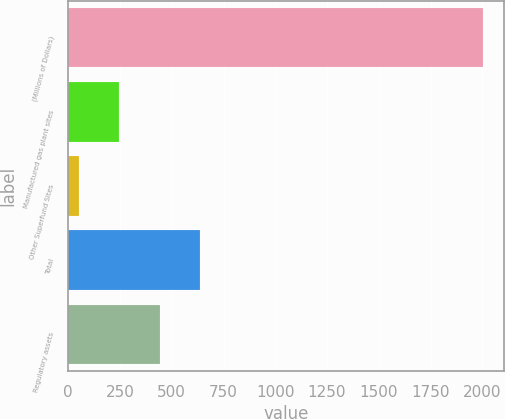Convert chart. <chart><loc_0><loc_0><loc_500><loc_500><bar_chart><fcel>(Millions of Dollars)<fcel>Manufactured gas plant sites<fcel>Other Superfund Sites<fcel>Total<fcel>Regulatory assets<nl><fcel>2004<fcel>245.4<fcel>50<fcel>636.2<fcel>440.8<nl></chart> 